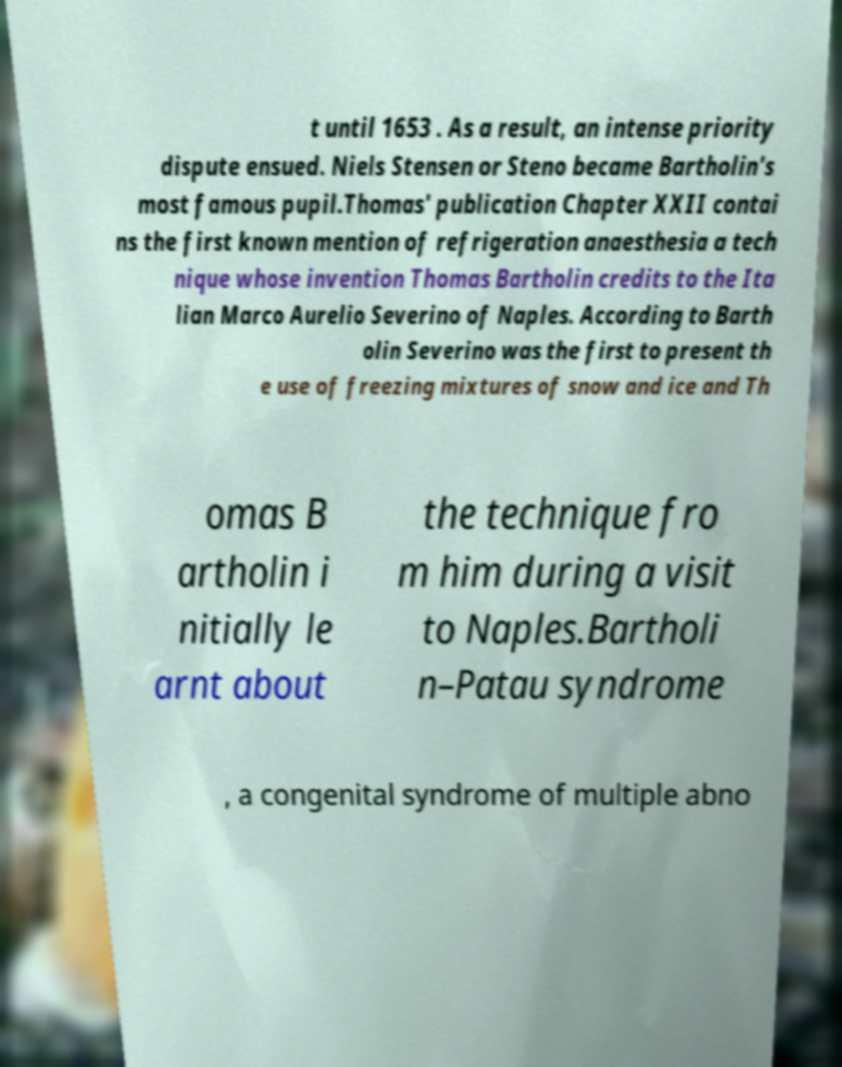Please read and relay the text visible in this image. What does it say? t until 1653 . As a result, an intense priority dispute ensued. Niels Stensen or Steno became Bartholin's most famous pupil.Thomas' publication Chapter XXII contai ns the first known mention of refrigeration anaesthesia a tech nique whose invention Thomas Bartholin credits to the Ita lian Marco Aurelio Severino of Naples. According to Barth olin Severino was the first to present th e use of freezing mixtures of snow and ice and Th omas B artholin i nitially le arnt about the technique fro m him during a visit to Naples.Bartholi n–Patau syndrome , a congenital syndrome of multiple abno 